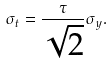Convert formula to latex. <formula><loc_0><loc_0><loc_500><loc_500>\sigma _ { t } = \frac { \tau } { \sqrt { 2 } } \sigma _ { y } .</formula> 